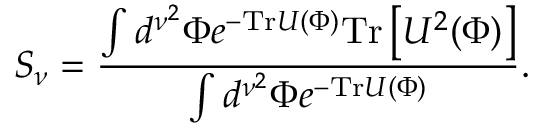<formula> <loc_0><loc_0><loc_500><loc_500>S _ { \nu } = { \frac { \int d ^ { \nu ^ { 2 } } \Phi e ^ { - T r U ( \Phi ) } T r \left [ U ^ { 2 } ( \Phi ) \right ] } { \int d ^ { \nu ^ { 2 } } \Phi e ^ { - T r U ( \Phi ) } } } .</formula> 